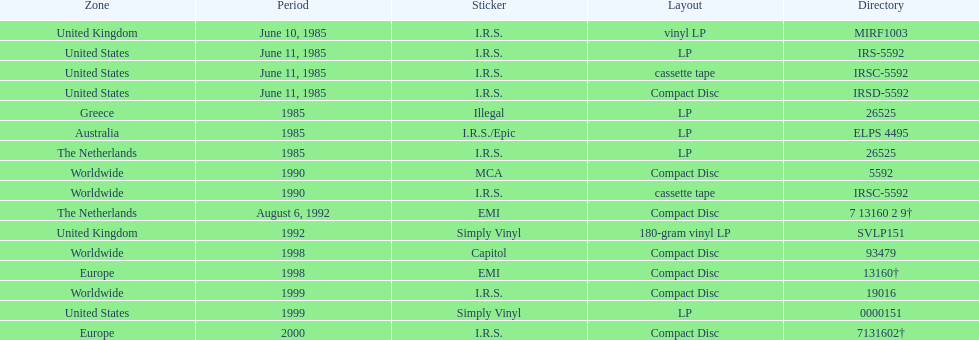Which region was the last to release? Europe. 